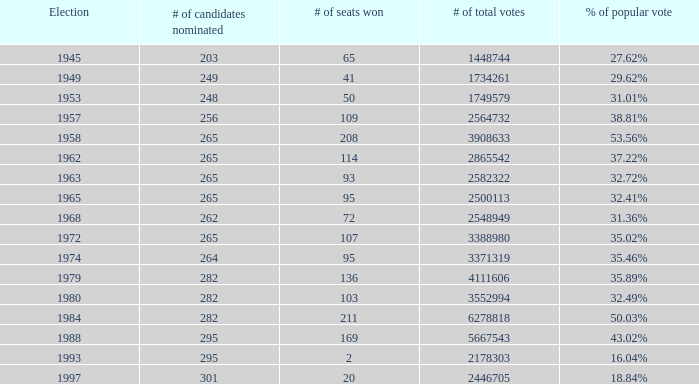What is the election year when the # of candidates nominated was 262? 1.0. 